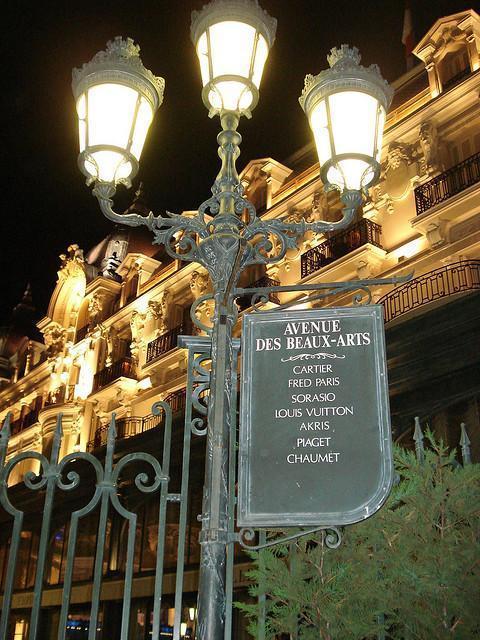How many lights are on the post?
Give a very brief answer. 3. 